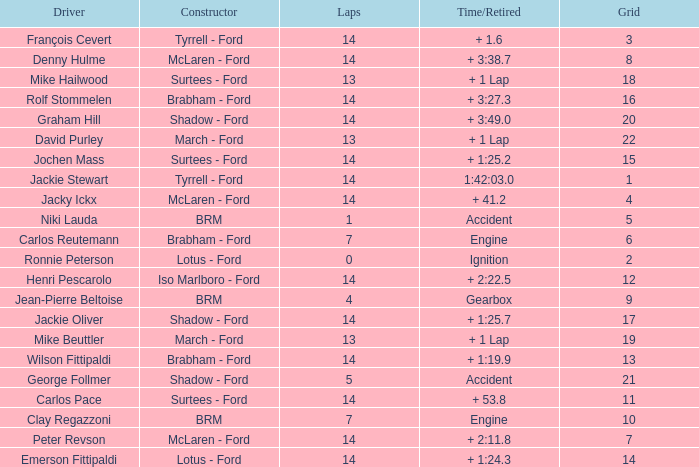What is the low lap total for a grid larger than 16 and has a Time/Retired of + 3:27.3? None. 